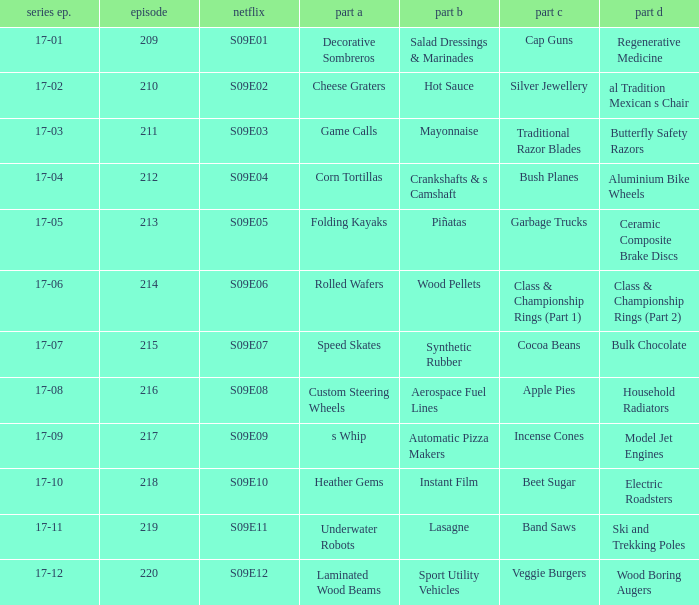For the shows featuring beet sugar, what was on before that Instant Film. 